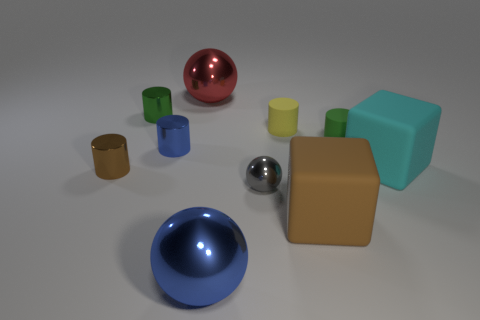Subtract all yellow cylinders. How many cylinders are left? 4 Subtract all blue cylinders. How many cylinders are left? 4 Subtract all red cylinders. Subtract all brown cubes. How many cylinders are left? 5 Subtract all cubes. How many objects are left? 8 Subtract 1 brown cylinders. How many objects are left? 9 Subtract all tiny blue matte spheres. Subtract all small blue cylinders. How many objects are left? 9 Add 6 tiny gray shiny things. How many tiny gray shiny things are left? 7 Add 2 yellow rubber things. How many yellow rubber things exist? 3 